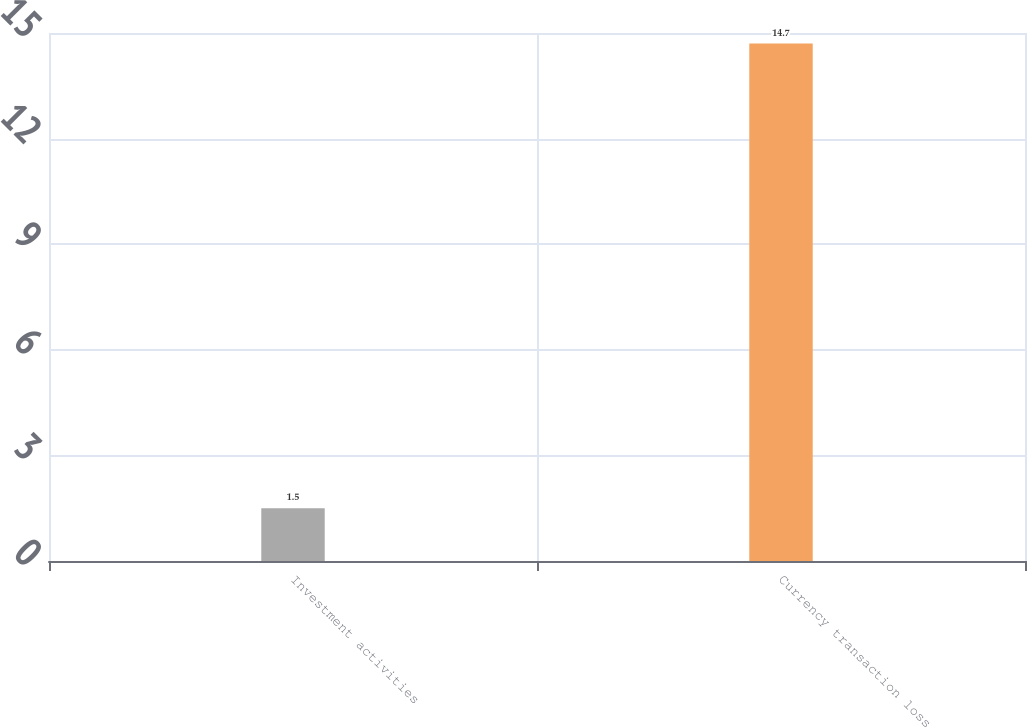<chart> <loc_0><loc_0><loc_500><loc_500><bar_chart><fcel>Investment activities<fcel>Currency transaction loss<nl><fcel>1.5<fcel>14.7<nl></chart> 